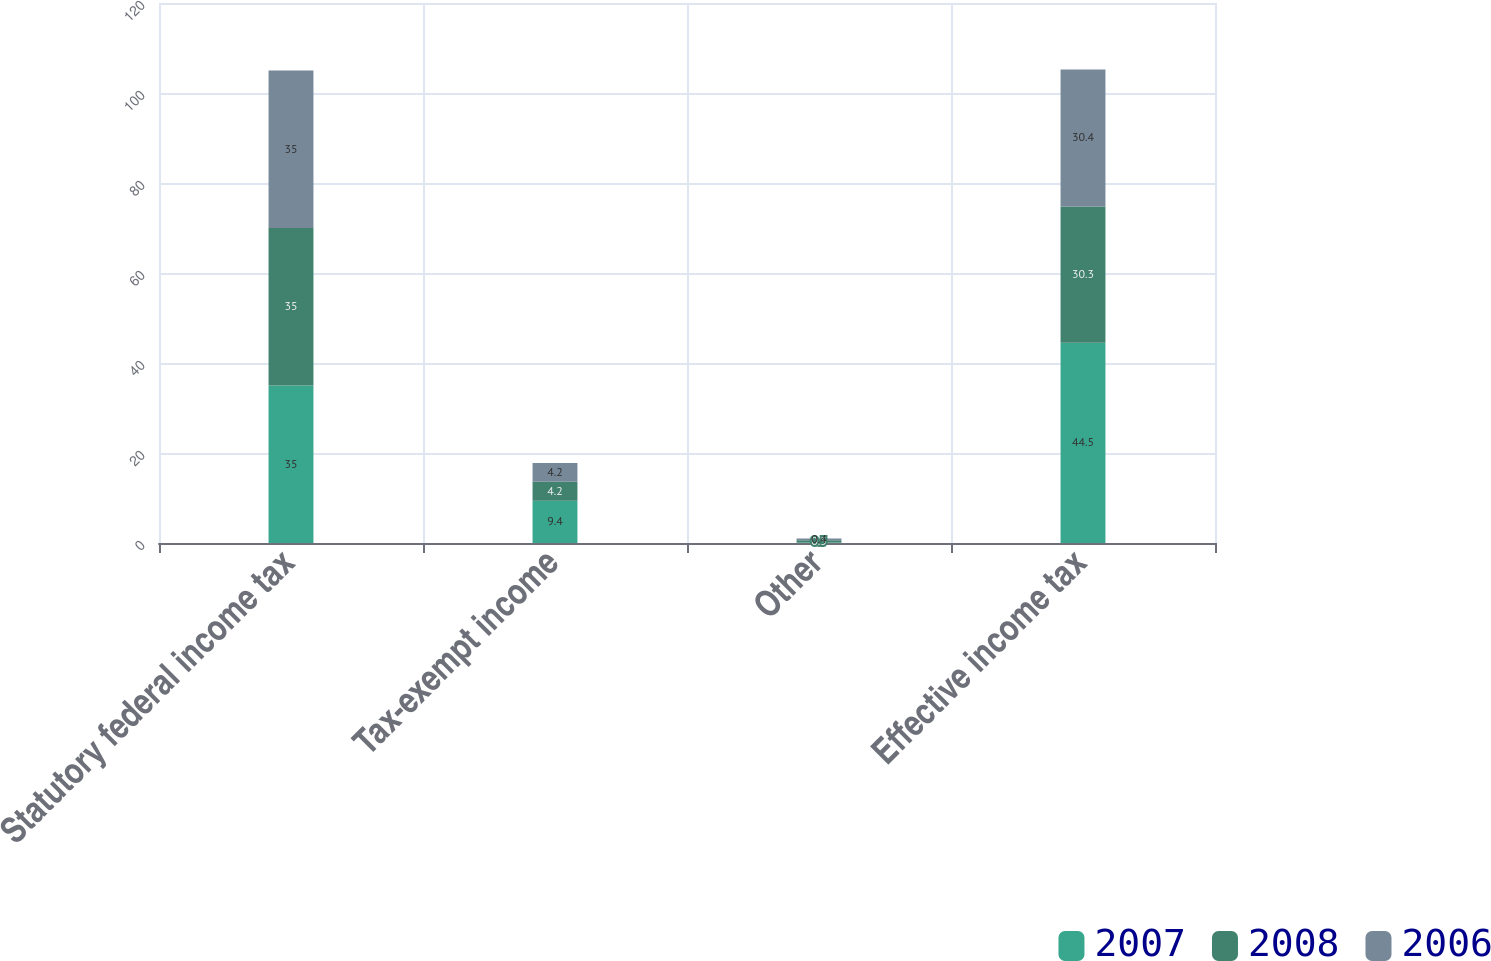Convert chart to OTSL. <chart><loc_0><loc_0><loc_500><loc_500><stacked_bar_chart><ecel><fcel>Statutory federal income tax<fcel>Tax-exempt income<fcel>Other<fcel>Effective income tax<nl><fcel>2007<fcel>35<fcel>9.4<fcel>0.1<fcel>44.5<nl><fcel>2008<fcel>35<fcel>4.2<fcel>0.5<fcel>30.3<nl><fcel>2006<fcel>35<fcel>4.2<fcel>0.4<fcel>30.4<nl></chart> 